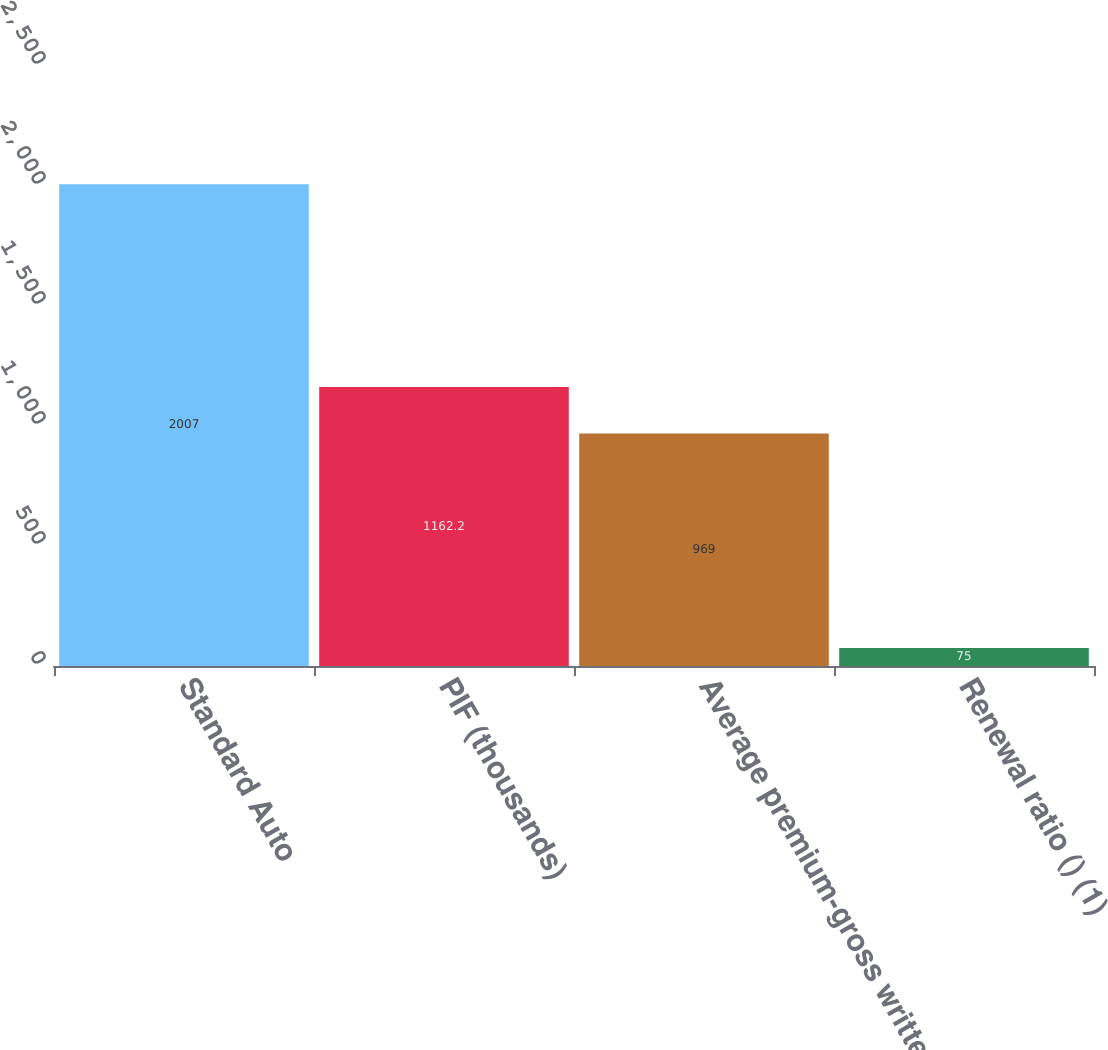Convert chart to OTSL. <chart><loc_0><loc_0><loc_500><loc_500><bar_chart><fcel>Standard Auto<fcel>PIF (thousands)<fcel>Average premium-gross written<fcel>Renewal ratio () (1)<nl><fcel>2007<fcel>1162.2<fcel>969<fcel>75<nl></chart> 